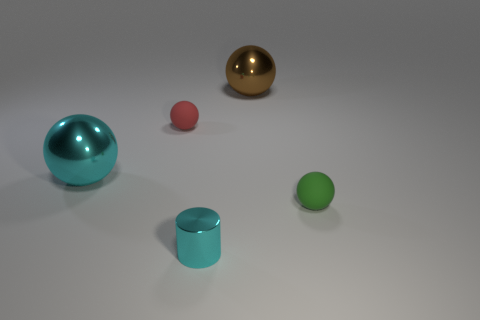Add 5 large brown objects. How many objects exist? 10 Subtract all red balls. How many balls are left? 3 Subtract all tiny red spheres. How many spheres are left? 3 Subtract 0 green cylinders. How many objects are left? 5 Subtract all balls. How many objects are left? 1 Subtract all purple balls. Subtract all blue cylinders. How many balls are left? 4 Subtract all red cylinders. How many brown spheres are left? 1 Subtract all big green metallic cubes. Subtract all cyan spheres. How many objects are left? 4 Add 4 matte spheres. How many matte spheres are left? 6 Add 4 brown shiny things. How many brown shiny things exist? 5 